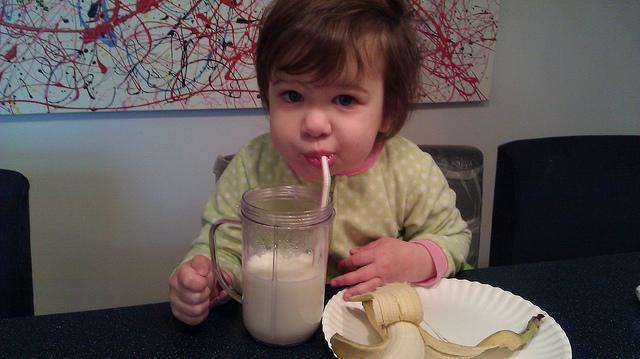What animal is known for eating the item on the plate?
Select the accurate answer and provide explanation: 'Answer: answer
Rationale: rationale.'
Options: Cheetah, badger, monkey, porcupine. Answer: monkey.
Rationale: Bananas are eaten by monkeys. 